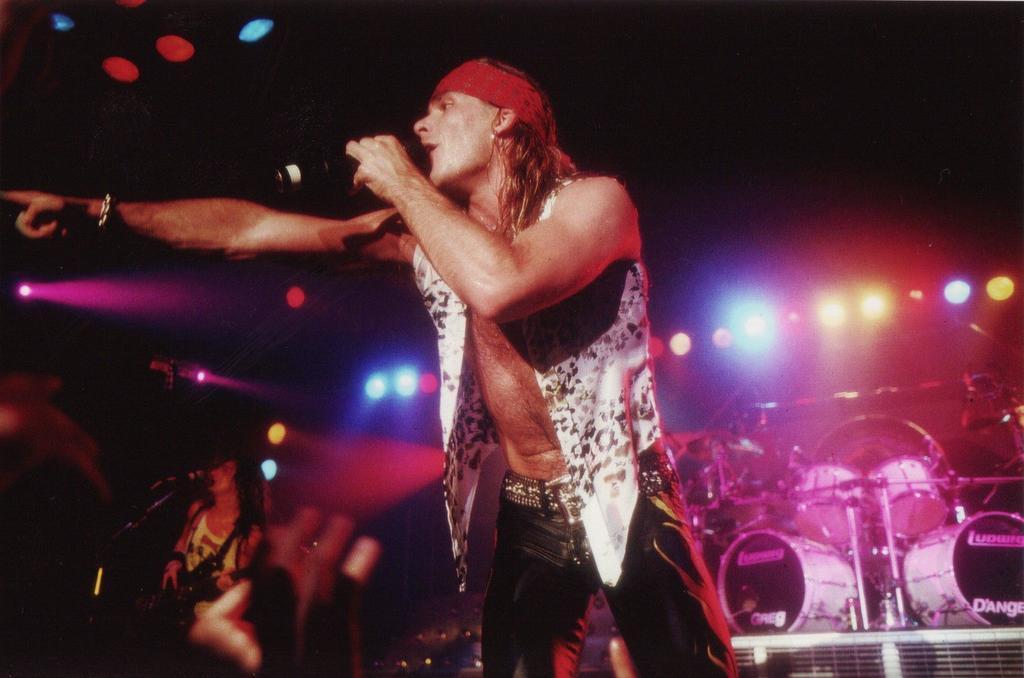Can you describe this image briefly? The picture is taken in a musical concert where a guy wearing a red hair band is singing with a mic in his hand. In the background there are few musical instruments with lights attached to the roof. 